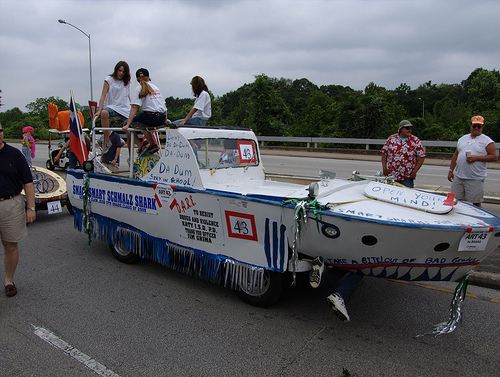<image>
Is there a woman on the boat? Yes. Looking at the image, I can see the woman is positioned on top of the boat, with the boat providing support. 